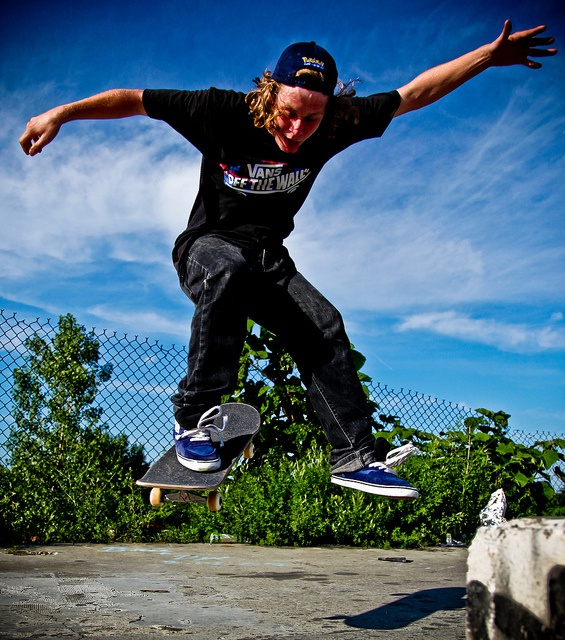Describe the objects in this image and their specific colors. I can see people in black, maroon, gray, and navy tones and skateboard in black, gray, and olive tones in this image. 